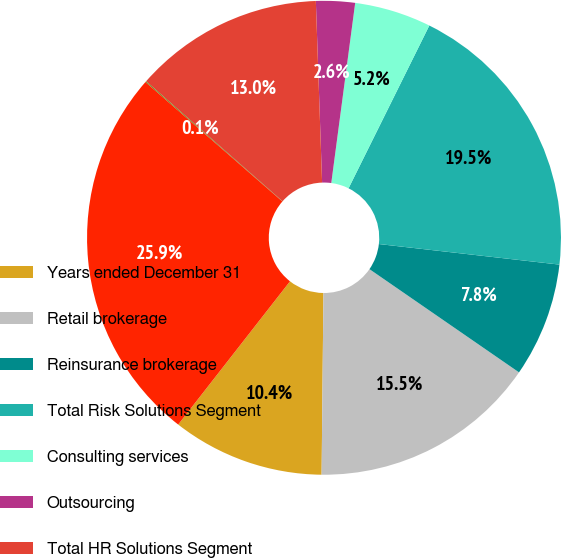<chart> <loc_0><loc_0><loc_500><loc_500><pie_chart><fcel>Years ended December 31<fcel>Retail brokerage<fcel>Reinsurance brokerage<fcel>Total Risk Solutions Segment<fcel>Consulting services<fcel>Outsourcing<fcel>Total HR Solutions Segment<fcel>Intersegment<fcel>Total commissions fees and<nl><fcel>10.39%<fcel>15.55%<fcel>7.81%<fcel>19.48%<fcel>5.23%<fcel>2.65%<fcel>12.97%<fcel>0.07%<fcel>25.87%<nl></chart> 